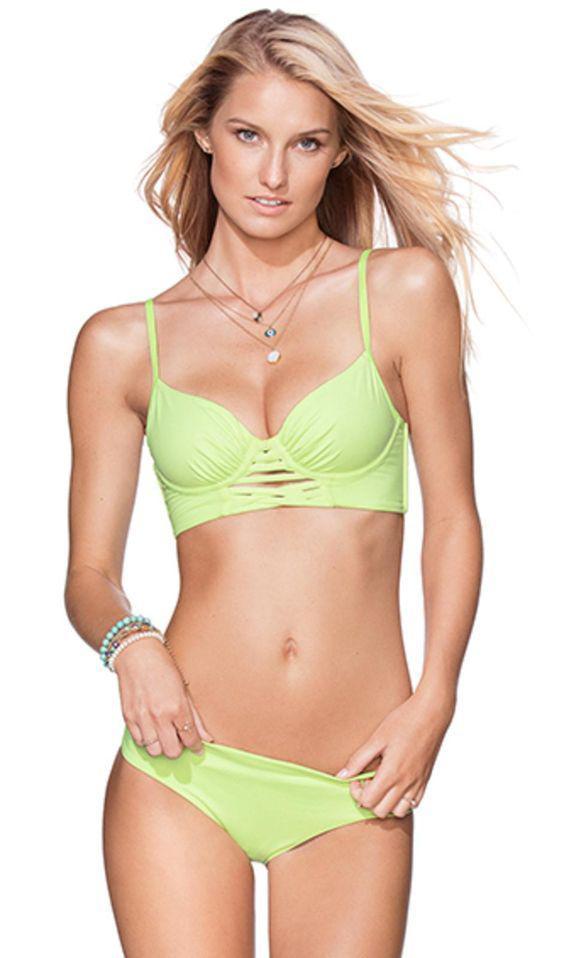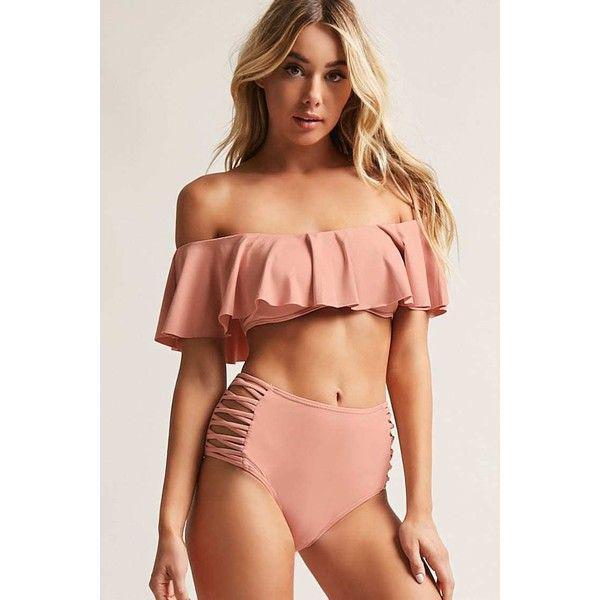The first image is the image on the left, the second image is the image on the right. For the images shown, is this caption "There is one green bikini" true? Answer yes or no. Yes. The first image is the image on the left, the second image is the image on the right. For the images displayed, is the sentence "A blonde model wears a light green bikini in one image." factually correct? Answer yes or no. Yes. 